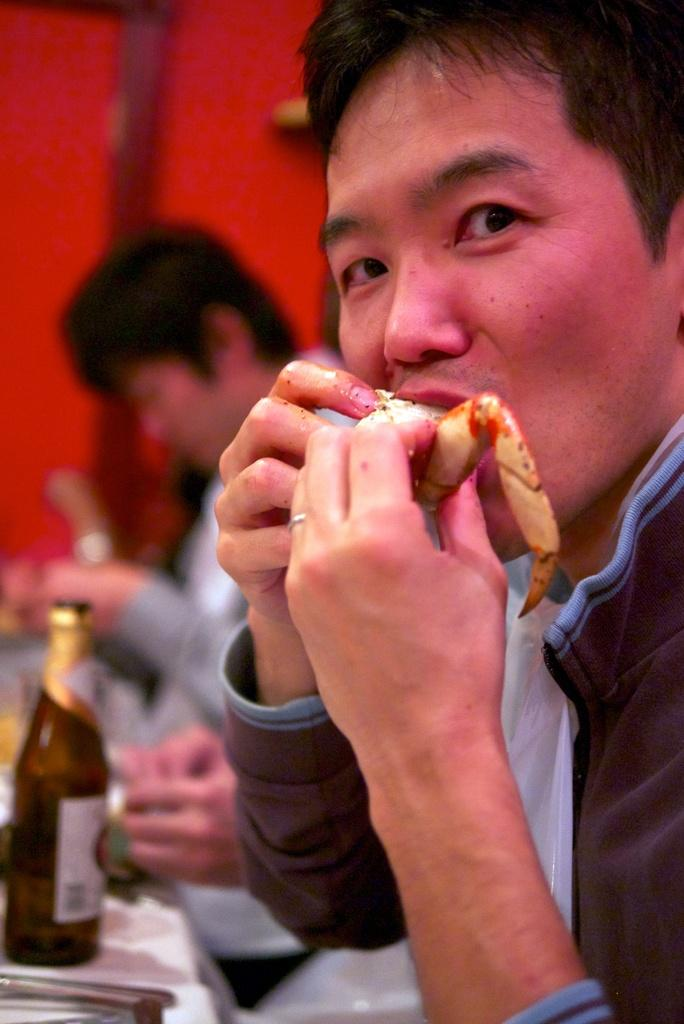How many people are in the image? There are two people in the image. What is one of the people doing in the image? One person is eating something. What object can be seen on the table in front of the people? There is a bottle on the table in the image. What type of advertisement is being displayed on the table in the image? There is no advertisement present in the image; it only features two people and a bottle on the table. Are the two people in the image kissing? There is no indication in the image that the two people are kissing. 